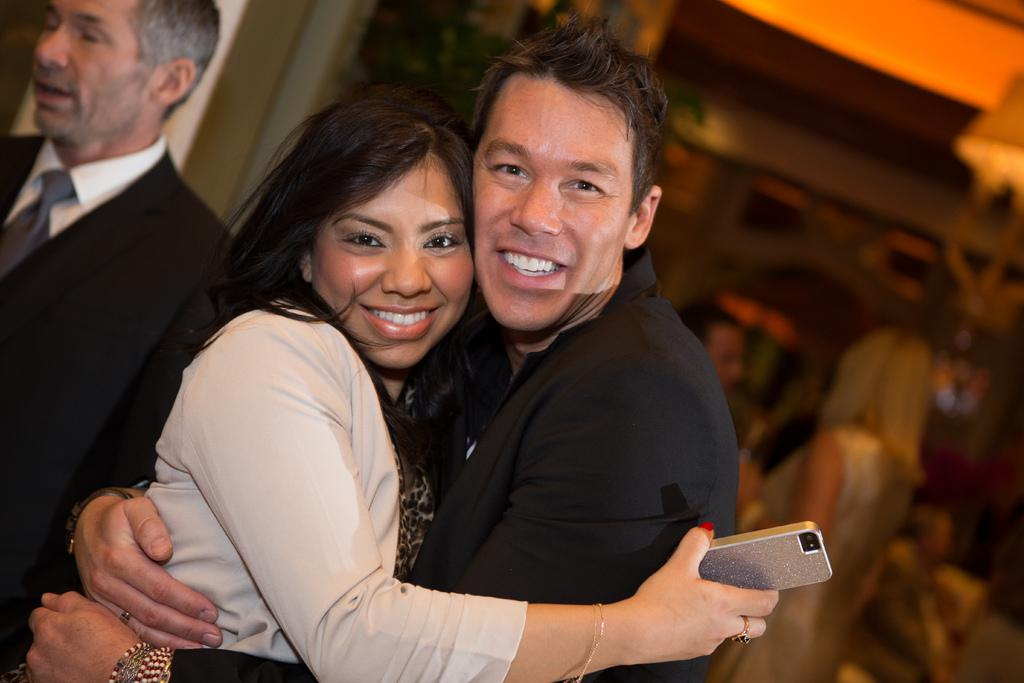How many people are in the image? There are two men and two women in the image. What are the two people of the opposite gender doing in the image? A man and a woman are hugging each other. What is the emotional expression of the hugging couple? The hugging couple is smiling. What type of society is depicted in the image? The image does not depict a society; it shows a hugging couple and two other individuals. How many mothers are present in the image? There is no mention of a mother or mothers in the image. 